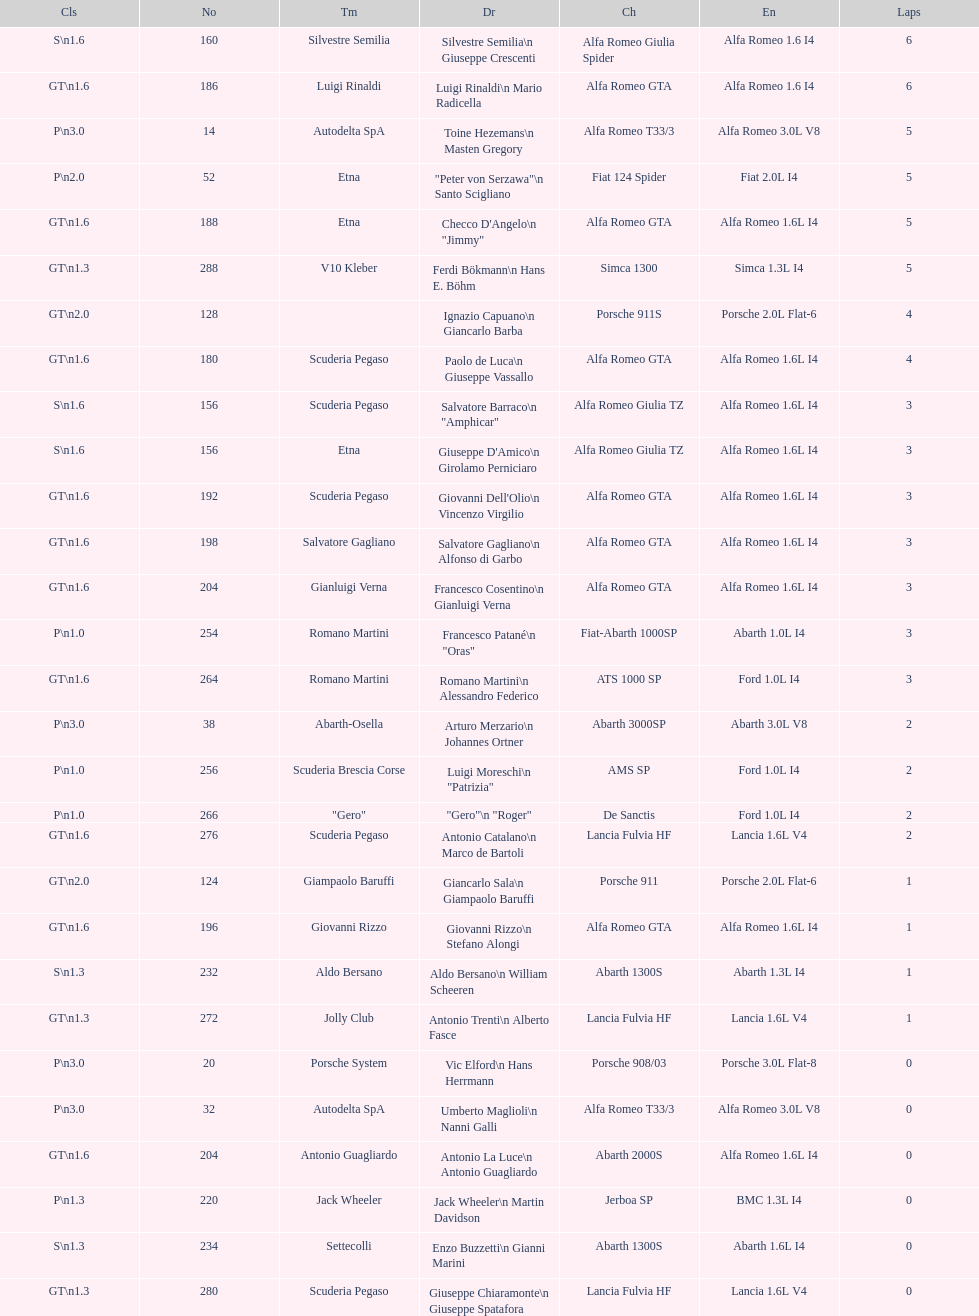How many laps does v10 kleber have? 5. 